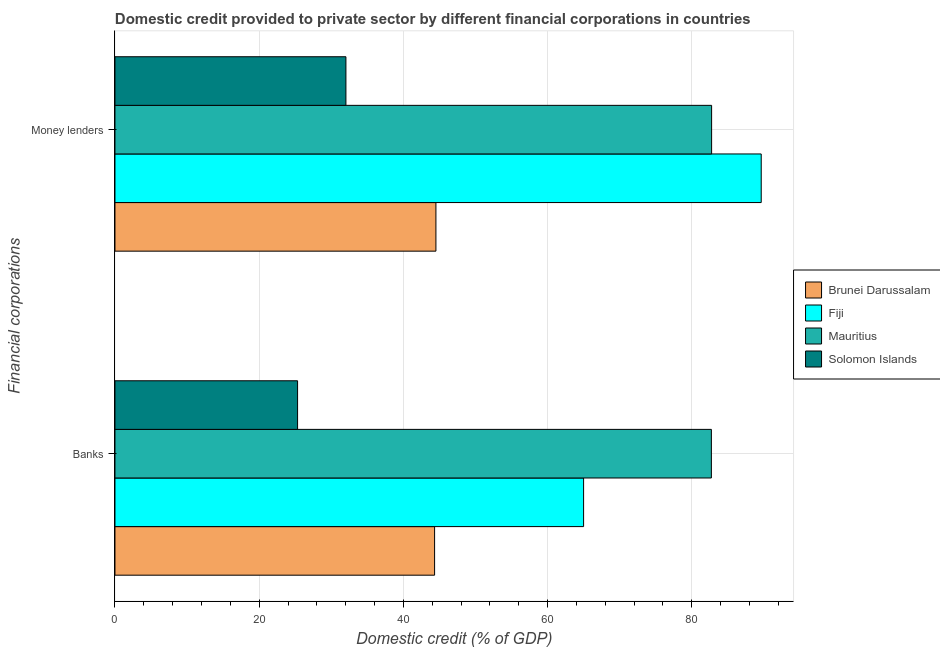How many different coloured bars are there?
Provide a short and direct response. 4. What is the label of the 2nd group of bars from the top?
Your answer should be compact. Banks. What is the domestic credit provided by banks in Mauritius?
Offer a terse response. 82.71. Across all countries, what is the maximum domestic credit provided by banks?
Provide a short and direct response. 82.71. Across all countries, what is the minimum domestic credit provided by money lenders?
Make the answer very short. 32.03. In which country was the domestic credit provided by banks maximum?
Provide a short and direct response. Mauritius. In which country was the domestic credit provided by banks minimum?
Offer a very short reply. Solomon Islands. What is the total domestic credit provided by banks in the graph?
Offer a terse response. 217.36. What is the difference between the domestic credit provided by banks in Fiji and that in Solomon Islands?
Ensure brevity in your answer.  39.66. What is the difference between the domestic credit provided by banks in Fiji and the domestic credit provided by money lenders in Brunei Darussalam?
Offer a very short reply. 20.48. What is the average domestic credit provided by banks per country?
Provide a succinct answer. 54.34. What is the difference between the domestic credit provided by money lenders and domestic credit provided by banks in Brunei Darussalam?
Provide a short and direct response. 0.18. What is the ratio of the domestic credit provided by banks in Mauritius to that in Fiji?
Provide a short and direct response. 1.27. Is the domestic credit provided by money lenders in Fiji less than that in Brunei Darussalam?
Your answer should be very brief. No. What does the 1st bar from the top in Banks represents?
Your answer should be very brief. Solomon Islands. What does the 1st bar from the bottom in Banks represents?
Your response must be concise. Brunei Darussalam. How many bars are there?
Your answer should be very brief. 8. Are all the bars in the graph horizontal?
Provide a succinct answer. Yes. Are the values on the major ticks of X-axis written in scientific E-notation?
Ensure brevity in your answer.  No. How many legend labels are there?
Offer a very short reply. 4. What is the title of the graph?
Provide a short and direct response. Domestic credit provided to private sector by different financial corporations in countries. What is the label or title of the X-axis?
Keep it short and to the point. Domestic credit (% of GDP). What is the label or title of the Y-axis?
Give a very brief answer. Financial corporations. What is the Domestic credit (% of GDP) in Brunei Darussalam in Banks?
Give a very brief answer. 44.33. What is the Domestic credit (% of GDP) of Fiji in Banks?
Your response must be concise. 64.99. What is the Domestic credit (% of GDP) in Mauritius in Banks?
Offer a terse response. 82.71. What is the Domestic credit (% of GDP) in Solomon Islands in Banks?
Ensure brevity in your answer.  25.33. What is the Domestic credit (% of GDP) in Brunei Darussalam in Money lenders?
Provide a short and direct response. 44.51. What is the Domestic credit (% of GDP) of Fiji in Money lenders?
Make the answer very short. 89.62. What is the Domestic credit (% of GDP) of Mauritius in Money lenders?
Your answer should be compact. 82.74. What is the Domestic credit (% of GDP) of Solomon Islands in Money lenders?
Give a very brief answer. 32.03. Across all Financial corporations, what is the maximum Domestic credit (% of GDP) in Brunei Darussalam?
Provide a short and direct response. 44.51. Across all Financial corporations, what is the maximum Domestic credit (% of GDP) of Fiji?
Offer a very short reply. 89.62. Across all Financial corporations, what is the maximum Domestic credit (% of GDP) in Mauritius?
Offer a terse response. 82.74. Across all Financial corporations, what is the maximum Domestic credit (% of GDP) in Solomon Islands?
Offer a terse response. 32.03. Across all Financial corporations, what is the minimum Domestic credit (% of GDP) in Brunei Darussalam?
Ensure brevity in your answer.  44.33. Across all Financial corporations, what is the minimum Domestic credit (% of GDP) in Fiji?
Your answer should be compact. 64.99. Across all Financial corporations, what is the minimum Domestic credit (% of GDP) in Mauritius?
Your response must be concise. 82.71. Across all Financial corporations, what is the minimum Domestic credit (% of GDP) of Solomon Islands?
Ensure brevity in your answer.  25.33. What is the total Domestic credit (% of GDP) of Brunei Darussalam in the graph?
Provide a short and direct response. 88.84. What is the total Domestic credit (% of GDP) in Fiji in the graph?
Provide a succinct answer. 154.62. What is the total Domestic credit (% of GDP) of Mauritius in the graph?
Your answer should be very brief. 165.45. What is the total Domestic credit (% of GDP) in Solomon Islands in the graph?
Offer a terse response. 57.36. What is the difference between the Domestic credit (% of GDP) of Brunei Darussalam in Banks and that in Money lenders?
Offer a very short reply. -0.18. What is the difference between the Domestic credit (% of GDP) in Fiji in Banks and that in Money lenders?
Offer a very short reply. -24.63. What is the difference between the Domestic credit (% of GDP) of Mauritius in Banks and that in Money lenders?
Provide a short and direct response. -0.03. What is the difference between the Domestic credit (% of GDP) of Solomon Islands in Banks and that in Money lenders?
Offer a very short reply. -6.71. What is the difference between the Domestic credit (% of GDP) in Brunei Darussalam in Banks and the Domestic credit (% of GDP) in Fiji in Money lenders?
Give a very brief answer. -45.3. What is the difference between the Domestic credit (% of GDP) of Brunei Darussalam in Banks and the Domestic credit (% of GDP) of Mauritius in Money lenders?
Keep it short and to the point. -38.42. What is the difference between the Domestic credit (% of GDP) of Brunei Darussalam in Banks and the Domestic credit (% of GDP) of Solomon Islands in Money lenders?
Provide a succinct answer. 12.3. What is the difference between the Domestic credit (% of GDP) of Fiji in Banks and the Domestic credit (% of GDP) of Mauritius in Money lenders?
Provide a short and direct response. -17.75. What is the difference between the Domestic credit (% of GDP) in Fiji in Banks and the Domestic credit (% of GDP) in Solomon Islands in Money lenders?
Your response must be concise. 32.96. What is the difference between the Domestic credit (% of GDP) of Mauritius in Banks and the Domestic credit (% of GDP) of Solomon Islands in Money lenders?
Give a very brief answer. 50.68. What is the average Domestic credit (% of GDP) in Brunei Darussalam per Financial corporations?
Your answer should be compact. 44.42. What is the average Domestic credit (% of GDP) in Fiji per Financial corporations?
Make the answer very short. 77.31. What is the average Domestic credit (% of GDP) in Mauritius per Financial corporations?
Provide a succinct answer. 82.73. What is the average Domestic credit (% of GDP) of Solomon Islands per Financial corporations?
Provide a succinct answer. 28.68. What is the difference between the Domestic credit (% of GDP) of Brunei Darussalam and Domestic credit (% of GDP) of Fiji in Banks?
Give a very brief answer. -20.66. What is the difference between the Domestic credit (% of GDP) in Brunei Darussalam and Domestic credit (% of GDP) in Mauritius in Banks?
Ensure brevity in your answer.  -38.38. What is the difference between the Domestic credit (% of GDP) of Brunei Darussalam and Domestic credit (% of GDP) of Solomon Islands in Banks?
Your response must be concise. 19. What is the difference between the Domestic credit (% of GDP) of Fiji and Domestic credit (% of GDP) of Mauritius in Banks?
Ensure brevity in your answer.  -17.72. What is the difference between the Domestic credit (% of GDP) of Fiji and Domestic credit (% of GDP) of Solomon Islands in Banks?
Provide a short and direct response. 39.66. What is the difference between the Domestic credit (% of GDP) of Mauritius and Domestic credit (% of GDP) of Solomon Islands in Banks?
Give a very brief answer. 57.38. What is the difference between the Domestic credit (% of GDP) in Brunei Darussalam and Domestic credit (% of GDP) in Fiji in Money lenders?
Make the answer very short. -45.11. What is the difference between the Domestic credit (% of GDP) in Brunei Darussalam and Domestic credit (% of GDP) in Mauritius in Money lenders?
Ensure brevity in your answer.  -38.23. What is the difference between the Domestic credit (% of GDP) of Brunei Darussalam and Domestic credit (% of GDP) of Solomon Islands in Money lenders?
Give a very brief answer. 12.48. What is the difference between the Domestic credit (% of GDP) in Fiji and Domestic credit (% of GDP) in Mauritius in Money lenders?
Offer a very short reply. 6.88. What is the difference between the Domestic credit (% of GDP) in Fiji and Domestic credit (% of GDP) in Solomon Islands in Money lenders?
Make the answer very short. 57.59. What is the difference between the Domestic credit (% of GDP) in Mauritius and Domestic credit (% of GDP) in Solomon Islands in Money lenders?
Offer a terse response. 50.71. What is the ratio of the Domestic credit (% of GDP) of Fiji in Banks to that in Money lenders?
Your response must be concise. 0.73. What is the ratio of the Domestic credit (% of GDP) in Solomon Islands in Banks to that in Money lenders?
Your response must be concise. 0.79. What is the difference between the highest and the second highest Domestic credit (% of GDP) of Brunei Darussalam?
Provide a succinct answer. 0.18. What is the difference between the highest and the second highest Domestic credit (% of GDP) of Fiji?
Your answer should be very brief. 24.63. What is the difference between the highest and the second highest Domestic credit (% of GDP) of Mauritius?
Offer a very short reply. 0.03. What is the difference between the highest and the second highest Domestic credit (% of GDP) in Solomon Islands?
Keep it short and to the point. 6.71. What is the difference between the highest and the lowest Domestic credit (% of GDP) in Brunei Darussalam?
Make the answer very short. 0.18. What is the difference between the highest and the lowest Domestic credit (% of GDP) in Fiji?
Ensure brevity in your answer.  24.63. What is the difference between the highest and the lowest Domestic credit (% of GDP) in Mauritius?
Offer a very short reply. 0.03. What is the difference between the highest and the lowest Domestic credit (% of GDP) of Solomon Islands?
Your response must be concise. 6.71. 